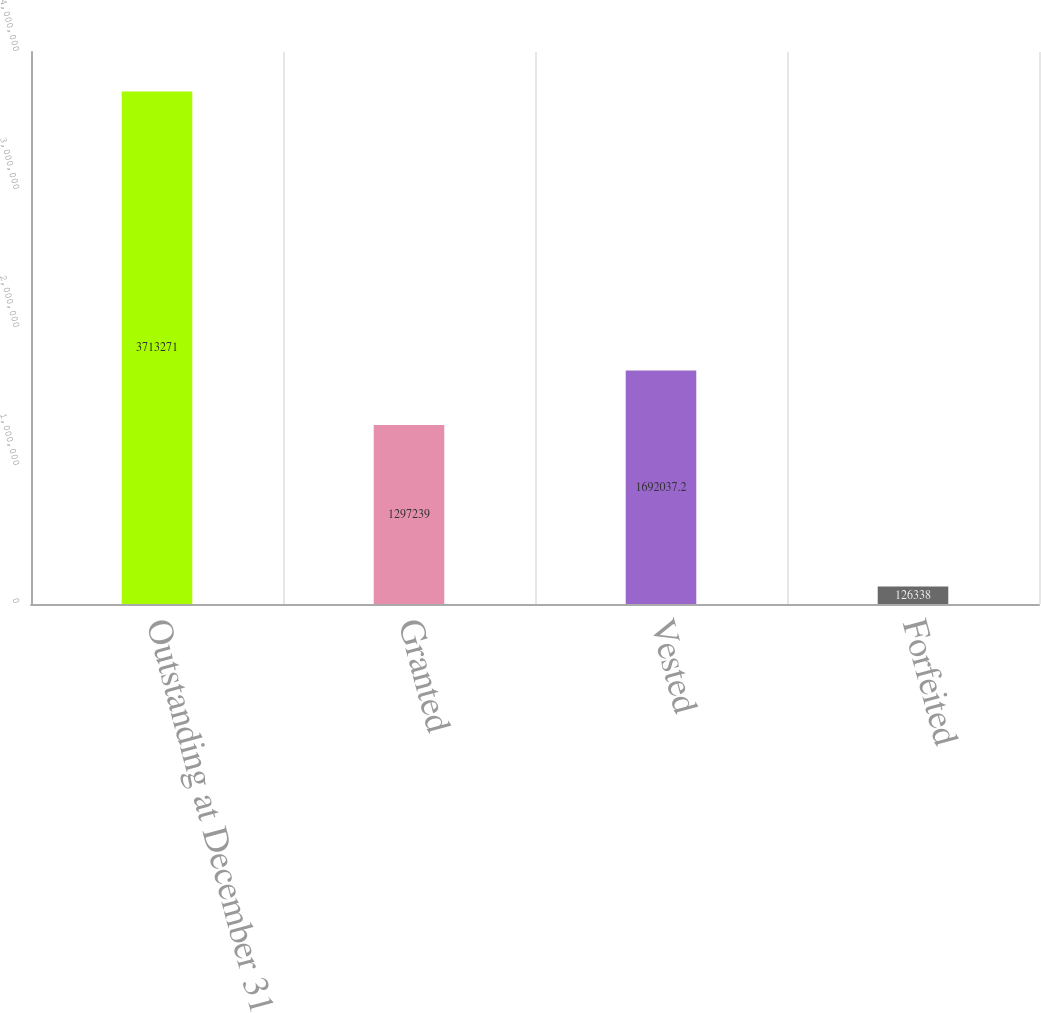Convert chart. <chart><loc_0><loc_0><loc_500><loc_500><bar_chart><fcel>Outstanding at December 31<fcel>Granted<fcel>Vested<fcel>Forfeited<nl><fcel>3.71327e+06<fcel>1.29724e+06<fcel>1.69204e+06<fcel>126338<nl></chart> 